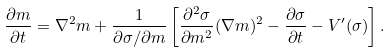<formula> <loc_0><loc_0><loc_500><loc_500>\frac { \partial m } { \partial t } = \nabla ^ { 2 } m + \frac { 1 } { { \partial \sigma } / { \partial m } } \left [ \frac { \partial ^ { 2 } \sigma } { \partial m ^ { 2 } } ( \nabla m ) ^ { 2 } - \frac { \partial \sigma } { \partial t } - V ^ { \prime } ( \sigma ) \right ] .</formula> 